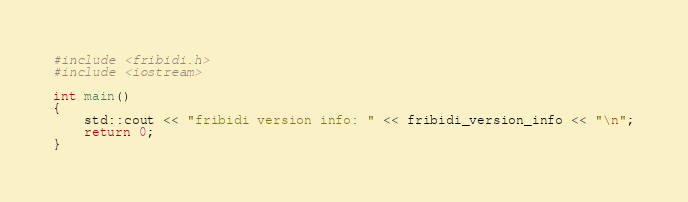<code> <loc_0><loc_0><loc_500><loc_500><_C++_>#include <fribidi.h>
#include <iostream>

int main()
{
    std::cout << "fribidi version info: " << fribidi_version_info << "\n";
    return 0;
}
</code> 